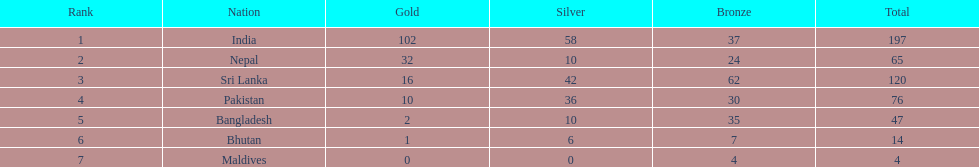Help me parse the entirety of this table. {'header': ['Rank', 'Nation', 'Gold', 'Silver', 'Bronze', 'Total'], 'rows': [['1', 'India', '102', '58', '37', '197'], ['2', 'Nepal', '32', '10', '24', '65'], ['3', 'Sri Lanka', '16', '42', '62', '120'], ['4', 'Pakistan', '10', '36', '30', '76'], ['5', 'Bangladesh', '2', '10', '35', '47'], ['6', 'Bhutan', '1', '6', '7', '14'], ['7', 'Maldives', '0', '0', '4', '4']]} How many countries have one more than 10 gold medals? 3. 